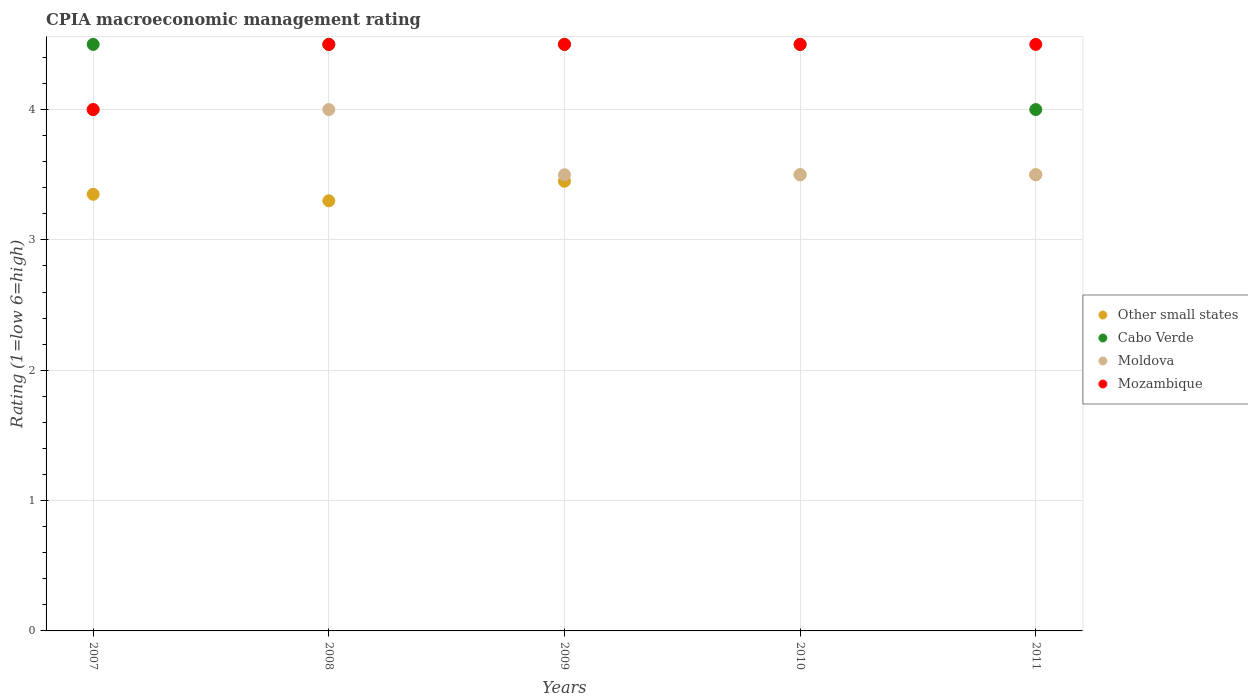How many different coloured dotlines are there?
Provide a short and direct response. 4. Is the number of dotlines equal to the number of legend labels?
Ensure brevity in your answer.  Yes. What is the CPIA rating in Cabo Verde in 2009?
Give a very brief answer. 4.5. Across all years, what is the maximum CPIA rating in Moldova?
Give a very brief answer. 4. In which year was the CPIA rating in Moldova minimum?
Your response must be concise. 2009. What is the total CPIA rating in Mozambique in the graph?
Offer a terse response. 22. What is the average CPIA rating in Other small states per year?
Your answer should be very brief. 3.42. In the year 2007, what is the difference between the CPIA rating in Cabo Verde and CPIA rating in Other small states?
Offer a terse response. 1.15. In how many years, is the CPIA rating in Other small states greater than 1.2?
Your response must be concise. 5. What is the ratio of the CPIA rating in Other small states in 2008 to that in 2009?
Give a very brief answer. 0.96. Is the CPIA rating in Mozambique in 2007 less than that in 2008?
Keep it short and to the point. Yes. What is the difference between the highest and the second highest CPIA rating in Moldova?
Your response must be concise. 0. What is the difference between the highest and the lowest CPIA rating in Other small states?
Your response must be concise. 0.2. Is the sum of the CPIA rating in Moldova in 2010 and 2011 greater than the maximum CPIA rating in Other small states across all years?
Your answer should be very brief. Yes. Is it the case that in every year, the sum of the CPIA rating in Cabo Verde and CPIA rating in Moldova  is greater than the sum of CPIA rating in Mozambique and CPIA rating in Other small states?
Offer a very short reply. Yes. Is it the case that in every year, the sum of the CPIA rating in Moldova and CPIA rating in Cabo Verde  is greater than the CPIA rating in Other small states?
Offer a very short reply. Yes. How many dotlines are there?
Provide a succinct answer. 4. How many years are there in the graph?
Offer a very short reply. 5. Does the graph contain grids?
Keep it short and to the point. Yes. How many legend labels are there?
Provide a short and direct response. 4. How are the legend labels stacked?
Make the answer very short. Vertical. What is the title of the graph?
Make the answer very short. CPIA macroeconomic management rating. Does "Algeria" appear as one of the legend labels in the graph?
Offer a very short reply. No. What is the label or title of the X-axis?
Give a very brief answer. Years. What is the label or title of the Y-axis?
Give a very brief answer. Rating (1=low 6=high). What is the Rating (1=low 6=high) in Other small states in 2007?
Your answer should be compact. 3.35. What is the Rating (1=low 6=high) in Mozambique in 2007?
Offer a terse response. 4. What is the Rating (1=low 6=high) in Other small states in 2008?
Your answer should be compact. 3.3. What is the Rating (1=low 6=high) of Cabo Verde in 2008?
Offer a very short reply. 4.5. What is the Rating (1=low 6=high) in Moldova in 2008?
Provide a short and direct response. 4. What is the Rating (1=low 6=high) in Mozambique in 2008?
Provide a succinct answer. 4.5. What is the Rating (1=low 6=high) of Other small states in 2009?
Provide a succinct answer. 3.45. What is the Rating (1=low 6=high) in Mozambique in 2009?
Offer a terse response. 4.5. What is the Rating (1=low 6=high) of Other small states in 2010?
Your answer should be very brief. 3.5. What is the Rating (1=low 6=high) of Cabo Verde in 2010?
Give a very brief answer. 4.5. What is the Rating (1=low 6=high) of Other small states in 2011?
Provide a short and direct response. 3.5. What is the Rating (1=low 6=high) of Cabo Verde in 2011?
Offer a terse response. 4. Across all years, what is the maximum Rating (1=low 6=high) of Other small states?
Offer a terse response. 3.5. Across all years, what is the maximum Rating (1=low 6=high) of Cabo Verde?
Give a very brief answer. 4.5. Across all years, what is the minimum Rating (1=low 6=high) in Cabo Verde?
Your answer should be very brief. 4. Across all years, what is the minimum Rating (1=low 6=high) in Mozambique?
Provide a short and direct response. 4. What is the difference between the Rating (1=low 6=high) of Moldova in 2007 and that in 2008?
Your response must be concise. 0. What is the difference between the Rating (1=low 6=high) of Other small states in 2007 and that in 2009?
Offer a very short reply. -0.1. What is the difference between the Rating (1=low 6=high) of Cabo Verde in 2007 and that in 2009?
Give a very brief answer. 0. What is the difference between the Rating (1=low 6=high) in Cabo Verde in 2007 and that in 2010?
Give a very brief answer. 0. What is the difference between the Rating (1=low 6=high) in Moldova in 2007 and that in 2010?
Offer a terse response. 0.5. What is the difference between the Rating (1=low 6=high) in Mozambique in 2007 and that in 2010?
Provide a short and direct response. -0.5. What is the difference between the Rating (1=low 6=high) in Cabo Verde in 2007 and that in 2011?
Offer a terse response. 0.5. What is the difference between the Rating (1=low 6=high) of Cabo Verde in 2008 and that in 2009?
Offer a very short reply. 0. What is the difference between the Rating (1=low 6=high) of Moldova in 2008 and that in 2009?
Make the answer very short. 0.5. What is the difference between the Rating (1=low 6=high) of Cabo Verde in 2008 and that in 2010?
Keep it short and to the point. 0. What is the difference between the Rating (1=low 6=high) of Other small states in 2008 and that in 2011?
Offer a terse response. -0.2. What is the difference between the Rating (1=low 6=high) of Cabo Verde in 2008 and that in 2011?
Offer a very short reply. 0.5. What is the difference between the Rating (1=low 6=high) of Moldova in 2008 and that in 2011?
Provide a short and direct response. 0.5. What is the difference between the Rating (1=low 6=high) in Mozambique in 2008 and that in 2011?
Make the answer very short. 0. What is the difference between the Rating (1=low 6=high) in Mozambique in 2009 and that in 2010?
Provide a succinct answer. 0. What is the difference between the Rating (1=low 6=high) of Cabo Verde in 2009 and that in 2011?
Keep it short and to the point. 0.5. What is the difference between the Rating (1=low 6=high) of Moldova in 2009 and that in 2011?
Your answer should be compact. 0. What is the difference between the Rating (1=low 6=high) of Moldova in 2010 and that in 2011?
Offer a terse response. 0. What is the difference between the Rating (1=low 6=high) of Other small states in 2007 and the Rating (1=low 6=high) of Cabo Verde in 2008?
Your answer should be very brief. -1.15. What is the difference between the Rating (1=low 6=high) in Other small states in 2007 and the Rating (1=low 6=high) in Moldova in 2008?
Give a very brief answer. -0.65. What is the difference between the Rating (1=low 6=high) of Other small states in 2007 and the Rating (1=low 6=high) of Mozambique in 2008?
Give a very brief answer. -1.15. What is the difference between the Rating (1=low 6=high) of Moldova in 2007 and the Rating (1=low 6=high) of Mozambique in 2008?
Give a very brief answer. -0.5. What is the difference between the Rating (1=low 6=high) of Other small states in 2007 and the Rating (1=low 6=high) of Cabo Verde in 2009?
Ensure brevity in your answer.  -1.15. What is the difference between the Rating (1=low 6=high) in Other small states in 2007 and the Rating (1=low 6=high) in Mozambique in 2009?
Make the answer very short. -1.15. What is the difference between the Rating (1=low 6=high) in Cabo Verde in 2007 and the Rating (1=low 6=high) in Mozambique in 2009?
Your answer should be very brief. 0. What is the difference between the Rating (1=low 6=high) of Other small states in 2007 and the Rating (1=low 6=high) of Cabo Verde in 2010?
Provide a short and direct response. -1.15. What is the difference between the Rating (1=low 6=high) in Other small states in 2007 and the Rating (1=low 6=high) in Mozambique in 2010?
Your answer should be compact. -1.15. What is the difference between the Rating (1=low 6=high) of Cabo Verde in 2007 and the Rating (1=low 6=high) of Mozambique in 2010?
Your answer should be compact. 0. What is the difference between the Rating (1=low 6=high) in Moldova in 2007 and the Rating (1=low 6=high) in Mozambique in 2010?
Make the answer very short. -0.5. What is the difference between the Rating (1=low 6=high) in Other small states in 2007 and the Rating (1=low 6=high) in Cabo Verde in 2011?
Your response must be concise. -0.65. What is the difference between the Rating (1=low 6=high) of Other small states in 2007 and the Rating (1=low 6=high) of Moldova in 2011?
Offer a very short reply. -0.15. What is the difference between the Rating (1=low 6=high) of Other small states in 2007 and the Rating (1=low 6=high) of Mozambique in 2011?
Ensure brevity in your answer.  -1.15. What is the difference between the Rating (1=low 6=high) of Moldova in 2007 and the Rating (1=low 6=high) of Mozambique in 2011?
Your response must be concise. -0.5. What is the difference between the Rating (1=low 6=high) of Other small states in 2008 and the Rating (1=low 6=high) of Cabo Verde in 2009?
Your answer should be very brief. -1.2. What is the difference between the Rating (1=low 6=high) of Cabo Verde in 2008 and the Rating (1=low 6=high) of Moldova in 2009?
Your response must be concise. 1. What is the difference between the Rating (1=low 6=high) in Cabo Verde in 2008 and the Rating (1=low 6=high) in Mozambique in 2009?
Provide a short and direct response. 0. What is the difference between the Rating (1=low 6=high) of Moldova in 2008 and the Rating (1=low 6=high) of Mozambique in 2009?
Provide a succinct answer. -0.5. What is the difference between the Rating (1=low 6=high) in Cabo Verde in 2008 and the Rating (1=low 6=high) in Moldova in 2010?
Offer a very short reply. 1. What is the difference between the Rating (1=low 6=high) of Cabo Verde in 2008 and the Rating (1=low 6=high) of Mozambique in 2010?
Make the answer very short. 0. What is the difference between the Rating (1=low 6=high) of Moldova in 2008 and the Rating (1=low 6=high) of Mozambique in 2010?
Your answer should be compact. -0.5. What is the difference between the Rating (1=low 6=high) of Other small states in 2008 and the Rating (1=low 6=high) of Cabo Verde in 2011?
Provide a succinct answer. -0.7. What is the difference between the Rating (1=low 6=high) in Cabo Verde in 2008 and the Rating (1=low 6=high) in Moldova in 2011?
Ensure brevity in your answer.  1. What is the difference between the Rating (1=low 6=high) of Cabo Verde in 2008 and the Rating (1=low 6=high) of Mozambique in 2011?
Your answer should be very brief. 0. What is the difference between the Rating (1=low 6=high) in Moldova in 2008 and the Rating (1=low 6=high) in Mozambique in 2011?
Offer a very short reply. -0.5. What is the difference between the Rating (1=low 6=high) in Other small states in 2009 and the Rating (1=low 6=high) in Cabo Verde in 2010?
Your response must be concise. -1.05. What is the difference between the Rating (1=low 6=high) of Other small states in 2009 and the Rating (1=low 6=high) of Mozambique in 2010?
Keep it short and to the point. -1.05. What is the difference between the Rating (1=low 6=high) of Cabo Verde in 2009 and the Rating (1=low 6=high) of Moldova in 2010?
Give a very brief answer. 1. What is the difference between the Rating (1=low 6=high) of Cabo Verde in 2009 and the Rating (1=low 6=high) of Mozambique in 2010?
Offer a terse response. 0. What is the difference between the Rating (1=low 6=high) in Other small states in 2009 and the Rating (1=low 6=high) in Cabo Verde in 2011?
Provide a short and direct response. -0.55. What is the difference between the Rating (1=low 6=high) of Other small states in 2009 and the Rating (1=low 6=high) of Mozambique in 2011?
Give a very brief answer. -1.05. What is the difference between the Rating (1=low 6=high) in Moldova in 2009 and the Rating (1=low 6=high) in Mozambique in 2011?
Offer a terse response. -1. What is the difference between the Rating (1=low 6=high) in Other small states in 2010 and the Rating (1=low 6=high) in Mozambique in 2011?
Offer a terse response. -1. What is the average Rating (1=low 6=high) in Other small states per year?
Your response must be concise. 3.42. What is the average Rating (1=low 6=high) of Cabo Verde per year?
Give a very brief answer. 4.4. What is the average Rating (1=low 6=high) in Moldova per year?
Offer a very short reply. 3.7. What is the average Rating (1=low 6=high) in Mozambique per year?
Keep it short and to the point. 4.4. In the year 2007, what is the difference between the Rating (1=low 6=high) of Other small states and Rating (1=low 6=high) of Cabo Verde?
Your answer should be compact. -1.15. In the year 2007, what is the difference between the Rating (1=low 6=high) in Other small states and Rating (1=low 6=high) in Moldova?
Provide a succinct answer. -0.65. In the year 2007, what is the difference between the Rating (1=low 6=high) in Other small states and Rating (1=low 6=high) in Mozambique?
Provide a succinct answer. -0.65. In the year 2007, what is the difference between the Rating (1=low 6=high) of Cabo Verde and Rating (1=low 6=high) of Mozambique?
Offer a very short reply. 0.5. In the year 2008, what is the difference between the Rating (1=low 6=high) in Other small states and Rating (1=low 6=high) in Cabo Verde?
Ensure brevity in your answer.  -1.2. In the year 2008, what is the difference between the Rating (1=low 6=high) in Other small states and Rating (1=low 6=high) in Moldova?
Your response must be concise. -0.7. In the year 2008, what is the difference between the Rating (1=low 6=high) of Other small states and Rating (1=low 6=high) of Mozambique?
Provide a short and direct response. -1.2. In the year 2008, what is the difference between the Rating (1=low 6=high) of Cabo Verde and Rating (1=low 6=high) of Moldova?
Ensure brevity in your answer.  0.5. In the year 2008, what is the difference between the Rating (1=low 6=high) of Cabo Verde and Rating (1=low 6=high) of Mozambique?
Keep it short and to the point. 0. In the year 2008, what is the difference between the Rating (1=low 6=high) of Moldova and Rating (1=low 6=high) of Mozambique?
Provide a succinct answer. -0.5. In the year 2009, what is the difference between the Rating (1=low 6=high) of Other small states and Rating (1=low 6=high) of Cabo Verde?
Your response must be concise. -1.05. In the year 2009, what is the difference between the Rating (1=low 6=high) in Other small states and Rating (1=low 6=high) in Mozambique?
Offer a very short reply. -1.05. In the year 2009, what is the difference between the Rating (1=low 6=high) of Cabo Verde and Rating (1=low 6=high) of Moldova?
Your answer should be very brief. 1. In the year 2009, what is the difference between the Rating (1=low 6=high) of Cabo Verde and Rating (1=low 6=high) of Mozambique?
Give a very brief answer. 0. In the year 2010, what is the difference between the Rating (1=low 6=high) in Other small states and Rating (1=low 6=high) in Cabo Verde?
Give a very brief answer. -1. In the year 2010, what is the difference between the Rating (1=low 6=high) in Other small states and Rating (1=low 6=high) in Moldova?
Offer a terse response. 0. In the year 2010, what is the difference between the Rating (1=low 6=high) in Cabo Verde and Rating (1=low 6=high) in Moldova?
Your answer should be very brief. 1. In the year 2010, what is the difference between the Rating (1=low 6=high) in Cabo Verde and Rating (1=low 6=high) in Mozambique?
Offer a terse response. 0. In the year 2010, what is the difference between the Rating (1=low 6=high) in Moldova and Rating (1=low 6=high) in Mozambique?
Give a very brief answer. -1. In the year 2011, what is the difference between the Rating (1=low 6=high) in Other small states and Rating (1=low 6=high) in Mozambique?
Offer a terse response. -1. In the year 2011, what is the difference between the Rating (1=low 6=high) of Moldova and Rating (1=low 6=high) of Mozambique?
Your answer should be compact. -1. What is the ratio of the Rating (1=low 6=high) of Other small states in 2007 to that in 2008?
Provide a short and direct response. 1.02. What is the ratio of the Rating (1=low 6=high) of Cabo Verde in 2007 to that in 2008?
Keep it short and to the point. 1. What is the ratio of the Rating (1=low 6=high) of Moldova in 2007 to that in 2008?
Offer a very short reply. 1. What is the ratio of the Rating (1=low 6=high) in Cabo Verde in 2007 to that in 2009?
Offer a very short reply. 1. What is the ratio of the Rating (1=low 6=high) in Mozambique in 2007 to that in 2009?
Your response must be concise. 0.89. What is the ratio of the Rating (1=low 6=high) of Other small states in 2007 to that in 2010?
Provide a succinct answer. 0.96. What is the ratio of the Rating (1=low 6=high) in Moldova in 2007 to that in 2010?
Make the answer very short. 1.14. What is the ratio of the Rating (1=low 6=high) of Other small states in 2007 to that in 2011?
Make the answer very short. 0.96. What is the ratio of the Rating (1=low 6=high) of Cabo Verde in 2007 to that in 2011?
Offer a terse response. 1.12. What is the ratio of the Rating (1=low 6=high) of Moldova in 2007 to that in 2011?
Provide a succinct answer. 1.14. What is the ratio of the Rating (1=low 6=high) of Other small states in 2008 to that in 2009?
Your response must be concise. 0.96. What is the ratio of the Rating (1=low 6=high) in Cabo Verde in 2008 to that in 2009?
Offer a very short reply. 1. What is the ratio of the Rating (1=low 6=high) of Mozambique in 2008 to that in 2009?
Your answer should be compact. 1. What is the ratio of the Rating (1=low 6=high) in Other small states in 2008 to that in 2010?
Your response must be concise. 0.94. What is the ratio of the Rating (1=low 6=high) in Cabo Verde in 2008 to that in 2010?
Offer a very short reply. 1. What is the ratio of the Rating (1=low 6=high) of Moldova in 2008 to that in 2010?
Your response must be concise. 1.14. What is the ratio of the Rating (1=low 6=high) of Other small states in 2008 to that in 2011?
Provide a succinct answer. 0.94. What is the ratio of the Rating (1=low 6=high) in Moldova in 2008 to that in 2011?
Offer a very short reply. 1.14. What is the ratio of the Rating (1=low 6=high) in Other small states in 2009 to that in 2010?
Your response must be concise. 0.99. What is the ratio of the Rating (1=low 6=high) in Cabo Verde in 2009 to that in 2010?
Ensure brevity in your answer.  1. What is the ratio of the Rating (1=low 6=high) in Other small states in 2009 to that in 2011?
Give a very brief answer. 0.99. What is the ratio of the Rating (1=low 6=high) in Cabo Verde in 2009 to that in 2011?
Make the answer very short. 1.12. What is the ratio of the Rating (1=low 6=high) in Other small states in 2010 to that in 2011?
Your response must be concise. 1. What is the difference between the highest and the second highest Rating (1=low 6=high) of Moldova?
Your response must be concise. 0. What is the difference between the highest and the second highest Rating (1=low 6=high) of Mozambique?
Keep it short and to the point. 0. What is the difference between the highest and the lowest Rating (1=low 6=high) of Moldova?
Keep it short and to the point. 0.5. 